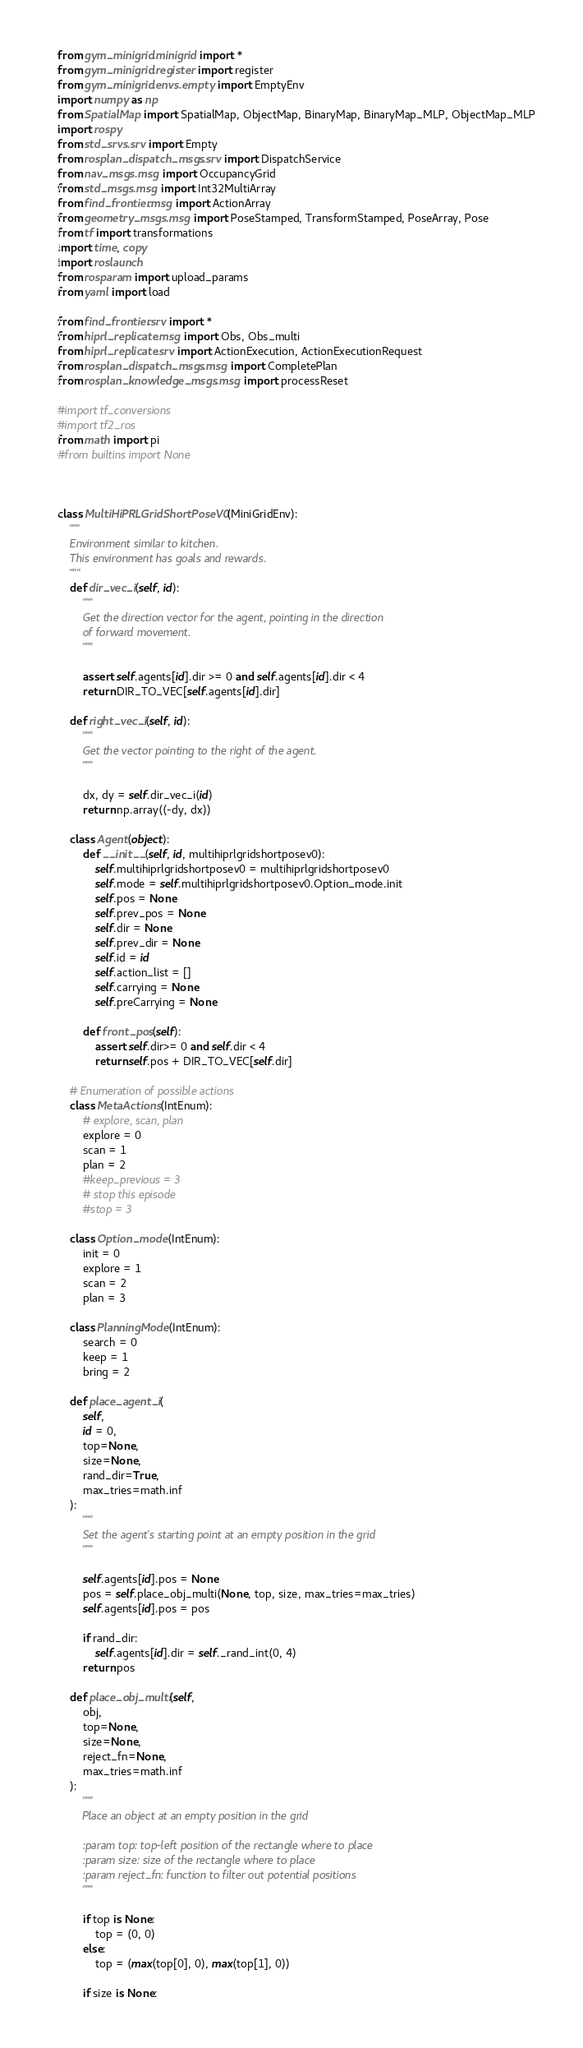<code> <loc_0><loc_0><loc_500><loc_500><_Python_>from gym_minigrid.minigrid import *
from gym_minigrid.register import register
from gym_minigrid.envs.empty import EmptyEnv
import numpy as np
from SpatialMap import SpatialMap, ObjectMap, BinaryMap, BinaryMap_MLP, ObjectMap_MLP
import rospy
from std_srvs.srv import Empty
from rosplan_dispatch_msgs.srv import DispatchService
from nav_msgs.msg import OccupancyGrid
from std_msgs.msg import Int32MultiArray
from find_frontier.msg import ActionArray
from geometry_msgs.msg import PoseStamped, TransformStamped, PoseArray, Pose
from tf import transformations
import time, copy
import roslaunch
from rosparam import upload_params
from yaml import load

from find_frontier.srv import *
from hiprl_replicate.msg import Obs, Obs_multi
from hiprl_replicate.srv import ActionExecution, ActionExecutionRequest
from rosplan_dispatch_msgs.msg import CompletePlan
from rosplan_knowledge_msgs.msg import processReset

#import tf_conversions
#import tf2_ros
from math import pi
#from builtins import None



class MultiHiPRLGridShortPoseV0(MiniGridEnv):
    """
    Environment similar to kitchen.
    This environment has goals and rewards.
    """
    def dir_vec_i(self, id):
        """
        Get the direction vector for the agent, pointing in the direction
        of forward movement.
        """

        assert self.agents[id].dir >= 0 and self.agents[id].dir < 4
        return DIR_TO_VEC[self.agents[id].dir]

    def right_vec_i(self, id):
        """
        Get the vector pointing to the right of the agent.
        """

        dx, dy = self.dir_vec_i(id)
        return np.array((-dy, dx))
    
    class Agent(object):
        def __init__(self, id, multihiprlgridshortposev0):
            self.multihiprlgridshortposev0 = multihiprlgridshortposev0
            self.mode = self.multihiprlgridshortposev0.Option_mode.init
            self.pos = None
            self.prev_pos = None
            self.dir = None
            self.prev_dir = None
            self.id = id
            self.action_list = []
            self.carrying = None
            self.preCarrying = None

        def front_pos(self):
            assert self.dir>= 0 and self.dir < 4
            return self.pos + DIR_TO_VEC[self.dir]

    # Enumeration of possible actions
    class MetaActions(IntEnum):
        # explore, scan, plan
        explore = 0
        scan = 1
        plan = 2
        #keep_previous = 3
        # stop this episode
        #stop = 3
    
    class Option_mode(IntEnum):
        init = 0
        explore = 1
        scan = 2
        plan = 3    
    
    class PlanningMode(IntEnum):
        search = 0
        keep = 1
        bring = 2
    
    def place_agent_i(
        self,
        id = 0,
        top=None,
        size=None,
        rand_dir=True,
        max_tries=math.inf
    ):
        """
        Set the agent's starting point at an empty position in the grid
        """

        self.agents[id].pos = None
        pos = self.place_obj_multi(None, top, size, max_tries=max_tries)
        self.agents[id].pos = pos

        if rand_dir:
            self.agents[id].dir = self._rand_int(0, 4)
        return pos
    
    def place_obj_multi(self,
        obj,
        top=None,
        size=None,
        reject_fn=None,
        max_tries=math.inf
    ):
        """
        Place an object at an empty position in the grid

        :param top: top-left position of the rectangle where to place
        :param size: size of the rectangle where to place
        :param reject_fn: function to filter out potential positions
        """

        if top is None:
            top = (0, 0)
        else:
            top = (max(top[0], 0), max(top[1], 0))

        if size is None:</code> 